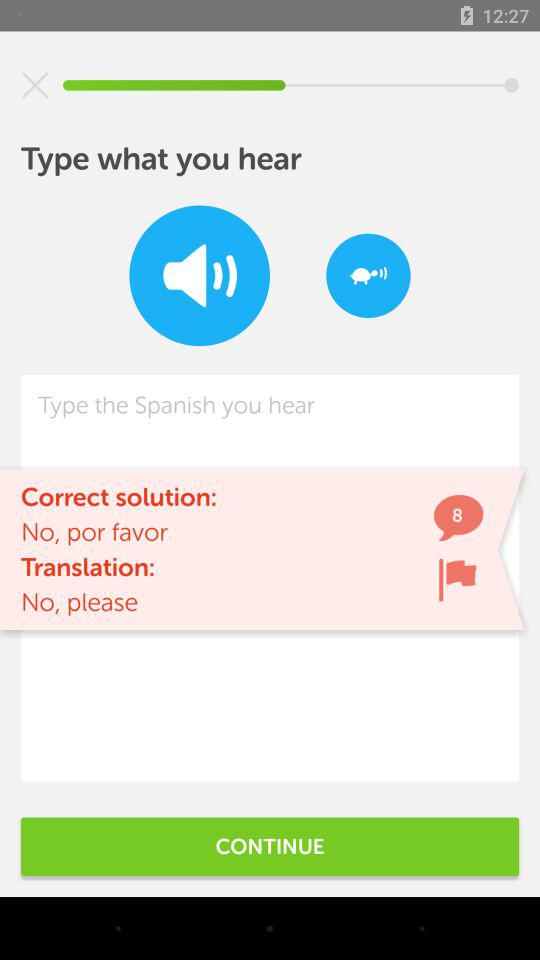What is typed into the text field?
When the provided information is insufficient, respond with <no answer>. <no answer> 